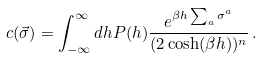Convert formula to latex. <formula><loc_0><loc_0><loc_500><loc_500>c ( \vec { \sigma } ) = \int _ { - \infty } ^ { \infty } d h P ( h ) \frac { e ^ { \beta h \sum _ { a } \sigma ^ { a } } } { ( 2 \cosh ( \beta h ) ) ^ { n } } \, .</formula> 